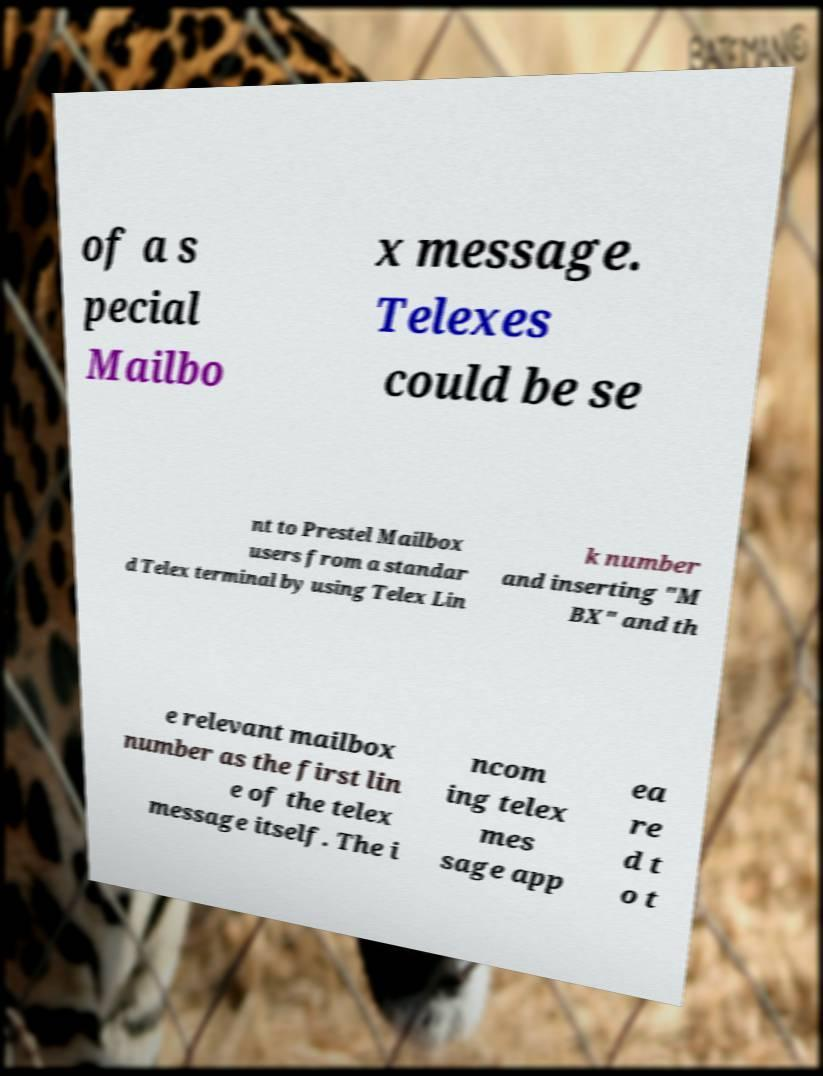Please identify and transcribe the text found in this image. of a s pecial Mailbo x message. Telexes could be se nt to Prestel Mailbox users from a standar d Telex terminal by using Telex Lin k number and inserting "M BX" and th e relevant mailbox number as the first lin e of the telex message itself. The i ncom ing telex mes sage app ea re d t o t 